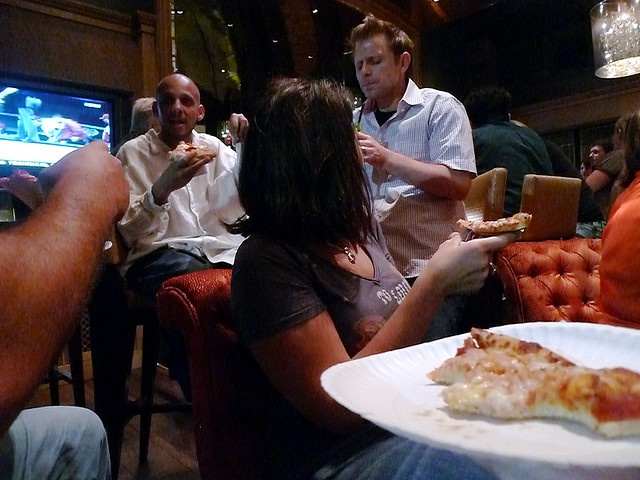Describe the objects in this image and their specific colors. I can see people in black, maroon, gray, and brown tones, people in black, maroon, brown, and darkgray tones, people in black, maroon, brown, and darkgray tones, people in black, darkgray, gray, and maroon tones, and pizza in black, tan, darkgray, and brown tones in this image. 